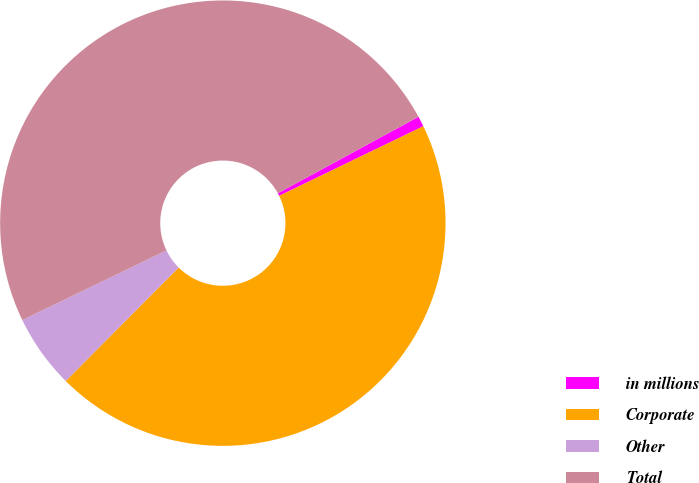<chart> <loc_0><loc_0><loc_500><loc_500><pie_chart><fcel>in millions<fcel>Corporate<fcel>Other<fcel>Total<nl><fcel>0.76%<fcel>44.63%<fcel>5.37%<fcel>49.24%<nl></chart> 